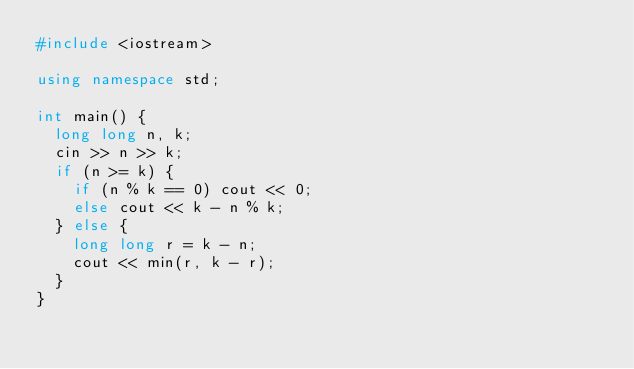<code> <loc_0><loc_0><loc_500><loc_500><_C++_>#include <iostream>

using namespace std;

int main() {
  long long n, k;
  cin >> n >> k;
  if (n >= k) {
    if (n % k == 0) cout << 0;
    else cout << k - n % k;
  } else {
    long long r = k - n;
    cout << min(r, k - r);
  }
}
</code> 